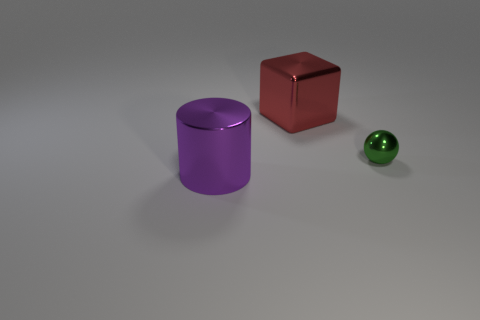Is there anything else that has the same size as the shiny sphere?
Ensure brevity in your answer.  No. Is the shape of the big shiny object to the right of the big purple thing the same as  the tiny green object?
Offer a terse response. No. What color is the object that is in front of the tiny shiny sphere?
Provide a succinct answer. Purple. What number of cubes are purple metal things or tiny green shiny objects?
Your response must be concise. 0. There is a shiny thing to the right of the thing that is behind the green ball; what is its size?
Offer a very short reply. Small. There is a large cylinder; does it have the same color as the object that is on the right side of the large block?
Your answer should be very brief. No. There is a large shiny cylinder; what number of objects are behind it?
Keep it short and to the point. 2. Is the number of tiny red matte cubes less than the number of big purple metal cylinders?
Your response must be concise. Yes. There is a object that is right of the purple shiny cylinder and in front of the metallic cube; what size is it?
Keep it short and to the point. Small. There is a big metallic object in front of the tiny metallic ball; does it have the same color as the tiny ball?
Ensure brevity in your answer.  No. 